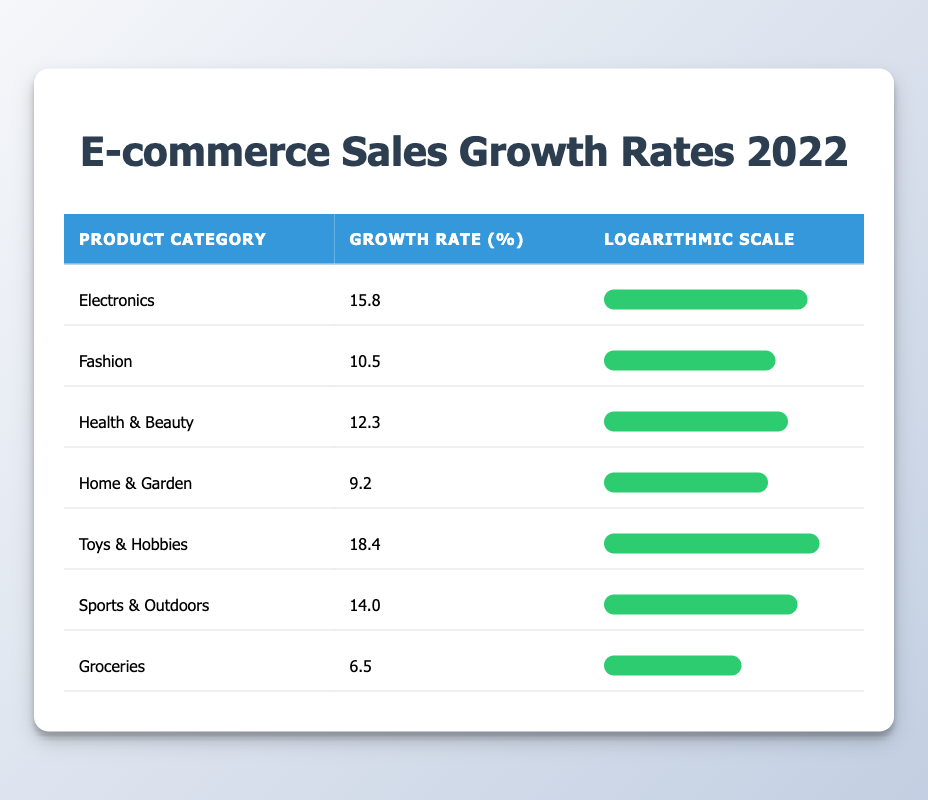What is the highest growth rate among the product categories? The table lists the growth rates for various product categories. By examining the "Growth Rate (%)" column, we see that "Toys & Hobbies" has the highest growth rate at 18.4%.
Answer: 18.4 Which product category had the lowest growth rate? From the "Growth Rate (%)" column in the table, "Groceries" has the lowest growth rate at 6.5%.
Answer: 6.5 What is the average growth rate of all product categories listed? To find the average growth rate, we sum all the growth rates: (15.8 + 10.5 + 12.3 + 9.2 + 18.4 + 14.0 + 6.5) = 86.7. There are 7 categories, so the average is 86.7 / 7 ≈ 12.39.
Answer: 12.39 Does "Health & Beauty" have a higher growth rate than "Fashion"? "Health & Beauty" has a growth rate of 12.3%, while "Fashion" has a growth rate of 10.5%. Since 12.3% is greater than 10.5%, the statement is true.
Answer: Yes If we compare the growth rates of "Electronics" and "Sports & Outdoors," which one is higher? "Electronics" has a growth rate of 15.8% and "Sports & Outdoors" has a growth rate of 14.0%. Since 15.8% is higher than 14.0%, "Electronics" has the higher growth rate.
Answer: Electronics 